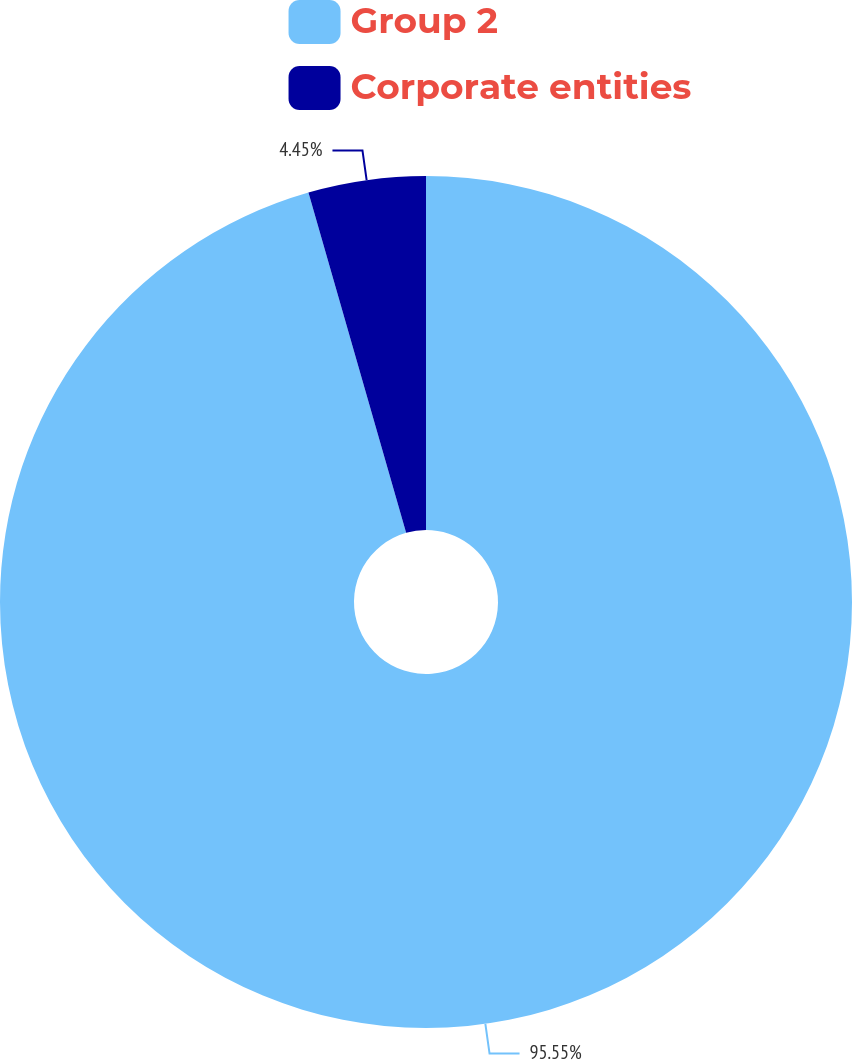Convert chart to OTSL. <chart><loc_0><loc_0><loc_500><loc_500><pie_chart><fcel>Group 2<fcel>Corporate entities<nl><fcel>95.55%<fcel>4.45%<nl></chart> 